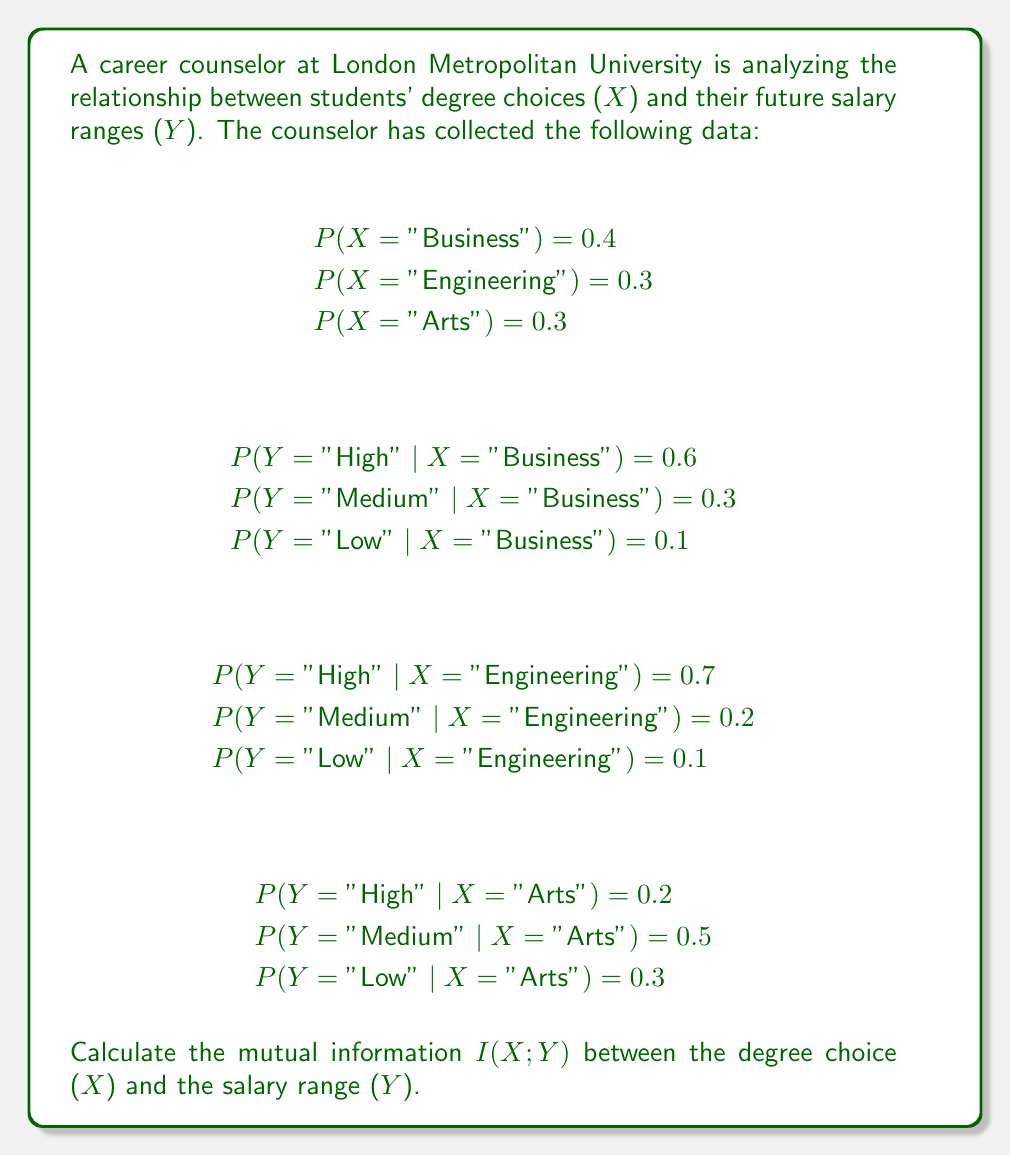Show me your answer to this math problem. To calculate the mutual information I(X;Y), we need to follow these steps:

1. Calculate P(Y) for each salary range.
2. Calculate P(X,Y) for each combination of degree and salary range.
3. Use the formula for mutual information:

$$I(X;Y) = \sum_{x \in X} \sum_{y \in Y} P(x,y) \log_2 \left(\frac{P(x,y)}{P(x)P(y)}\right)$$

Step 1: Calculate P(Y)

P(Y = "High") = 0.4 × 0.6 + 0.3 × 0.7 + 0.3 × 0.2 = 0.51
P(Y = "Medium") = 0.4 × 0.3 + 0.3 × 0.2 + 0.3 × 0.5 = 0.33
P(Y = "Low") = 0.4 × 0.1 + 0.3 × 0.1 + 0.3 × 0.3 = 0.16

Step 2: Calculate P(X,Y)

P(X = "Business", Y = "High") = 0.4 × 0.6 = 0.24
P(X = "Business", Y = "Medium") = 0.4 × 0.3 = 0.12
P(X = "Business", Y = "Low") = 0.4 × 0.1 = 0.04

P(X = "Engineering", Y = "High") = 0.3 × 0.7 = 0.21
P(X = "Engineering", Y = "Medium") = 0.3 × 0.2 = 0.06
P(X = "Engineering", Y = "Low") = 0.3 × 0.1 = 0.03

P(X = "Arts", Y = "High") = 0.3 × 0.2 = 0.06
P(X = "Arts", Y = "Medium") = 0.3 × 0.5 = 0.15
P(X = "Arts", Y = "Low") = 0.3 × 0.3 = 0.09

Step 3: Calculate I(X;Y)

$$\begin{align*}
I(X;Y) &= 0.24 \log_2 \left(\frac{0.24}{0.4 \times 0.51}\right) + 0.12 \log_2 \left(\frac{0.12}{0.4 \times 0.33}\right) + 0.04 \log_2 \left(\frac{0.04}{0.4 \times 0.16}\right) \\
&+ 0.21 \log_2 \left(\frac{0.21}{0.3 \times 0.51}\right) + 0.06 \log_2 \left(\frac{0.06}{0.3 \times 0.33}\right) + 0.03 \log_2 \left(\frac{0.03}{0.3 \times 0.16}\right) \\
&+ 0.06 \log_2 \left(\frac{0.06}{0.3 \times 0.51}\right) + 0.15 \log_2 \left(\frac{0.15}{0.3 \times 0.33}\right) + 0.09 \log_2 \left(\frac{0.09}{0.3 \times 0.16}\right)
\end{align*}$$

Calculating each term and summing them up:

$$I(X;Y) \approx 0.1038 + 0.0071 + 0.0000 + 0.1255 + 0.0000 + 0.0046 + (-0.1364) + 0.1167 + 0.1349$$
Answer: $$I(X;Y) \approx 0.3562 \text{ bits}$$ 